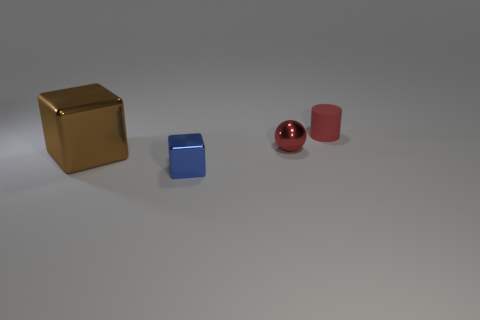How many metallic things are either big cyan objects or small things?
Make the answer very short. 2. Is there anything else that has the same size as the brown object?
Your response must be concise. No. The tiny sphere that is made of the same material as the small block is what color?
Your answer should be compact. Red. What number of cylinders are either large objects or tiny red shiny objects?
Provide a succinct answer. 0. What number of things are tiny cyan objects or blocks in front of the big brown block?
Ensure brevity in your answer.  1. Are there any yellow cylinders?
Your answer should be very brief. No. What number of objects have the same color as the shiny sphere?
Give a very brief answer. 1. What is the material of the object that is the same color as the small metal sphere?
Your response must be concise. Rubber. What size is the thing right of the metallic thing that is right of the blue metallic thing?
Your answer should be compact. Small. Is there another tiny block that has the same material as the brown block?
Keep it short and to the point. Yes. 